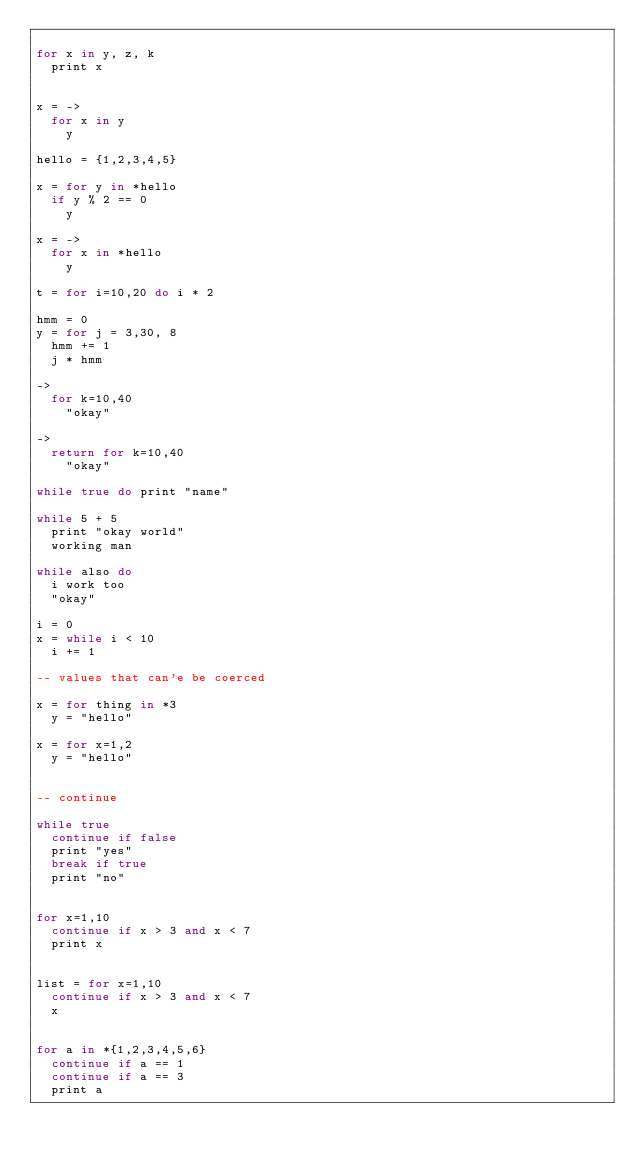Convert code to text. <code><loc_0><loc_0><loc_500><loc_500><_MoonScript_>
for x in y, z, k
  print x


x = ->
  for x in y
    y

hello = {1,2,3,4,5}

x = for y in *hello
  if y % 2 == 0
    y

x = ->
  for x in *hello
    y

t = for i=10,20 do i * 2

hmm = 0
y = for j = 3,30, 8
  hmm += 1
  j * hmm

->
  for k=10,40
    "okay"

->
  return for k=10,40
    "okay"

while true do print "name"

while 5 + 5
  print "okay world"
  working man

while also do
  i work too
  "okay"

i = 0
x = while i < 10
  i += 1

-- values that can'e be coerced

x = for thing in *3
  y = "hello"

x = for x=1,2
  y = "hello"


-- continue

while true
  continue if false
  print "yes"
  break if true
  print "no"


for x=1,10
  continue if x > 3 and x < 7
  print x


list = for x=1,10
  continue if x > 3 and x < 7
  x


for a in *{1,2,3,4,5,6}
  continue if a == 1
  continue if a == 3
  print a


</code> 